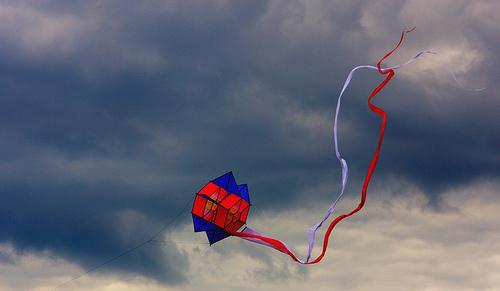Analyze the interaction between the main object and its surroundings. The woman in white swinging a tennis racket is actively engaging in the sport, while the kite and the stormy sky create a contrasting, dynamic background. Explain the features and design of the kite. The kite is red and blue, diamond-shaped with triangle blue wings, a long red and white tail, and a long black string. Assess the complexity of reasoning required for understanding the relationships between the main objects in the image. The complexity is moderate, as the relationships between the woman playing tennis, the flying kite, and the stormy sky are clearly depicted, though their interactions and influences on each other require some reasoning. What is the primary object in the image and what action is it engaged in? The main object is a woman in white swinging a tennis racket. Identify the sentiment of the image considering the elements and their interaction. The image evokes a sense of excitement and energy, with a woman playing tennis and a colorful kite flying in a stormy sky. Describe the condition of the sky in the image. The sky is blue and cloudy, with a darker and more stormy appearance in some areas. Count the number of individuals along with their basic activity in the image. There is one individual in the image - a woman in white swinging a tennis racket. Can you list the colors and shape of the kite in the image? The kite is red and blue, diamond-shaped with triangle blue wings. Mention any three major elements in the image and provide a brief description of each. 3. Sky - blue and cloudy, with a stormy atmosphere Comment on the image's quality considering the visibility and details of the elements. The image is of good quality, as the bounding boxes provide clear details and information on various elements and their positions. 